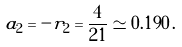Convert formula to latex. <formula><loc_0><loc_0><loc_500><loc_500>a _ { 2 } = - r _ { 2 } = \frac { 4 } { 2 1 } \simeq 0 . 1 9 0 \, .</formula> 